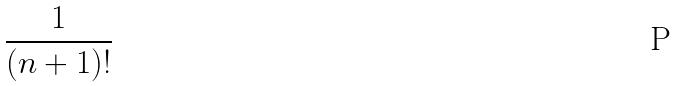Convert formula to latex. <formula><loc_0><loc_0><loc_500><loc_500>\frac { 1 } { ( n + 1 ) ! }</formula> 